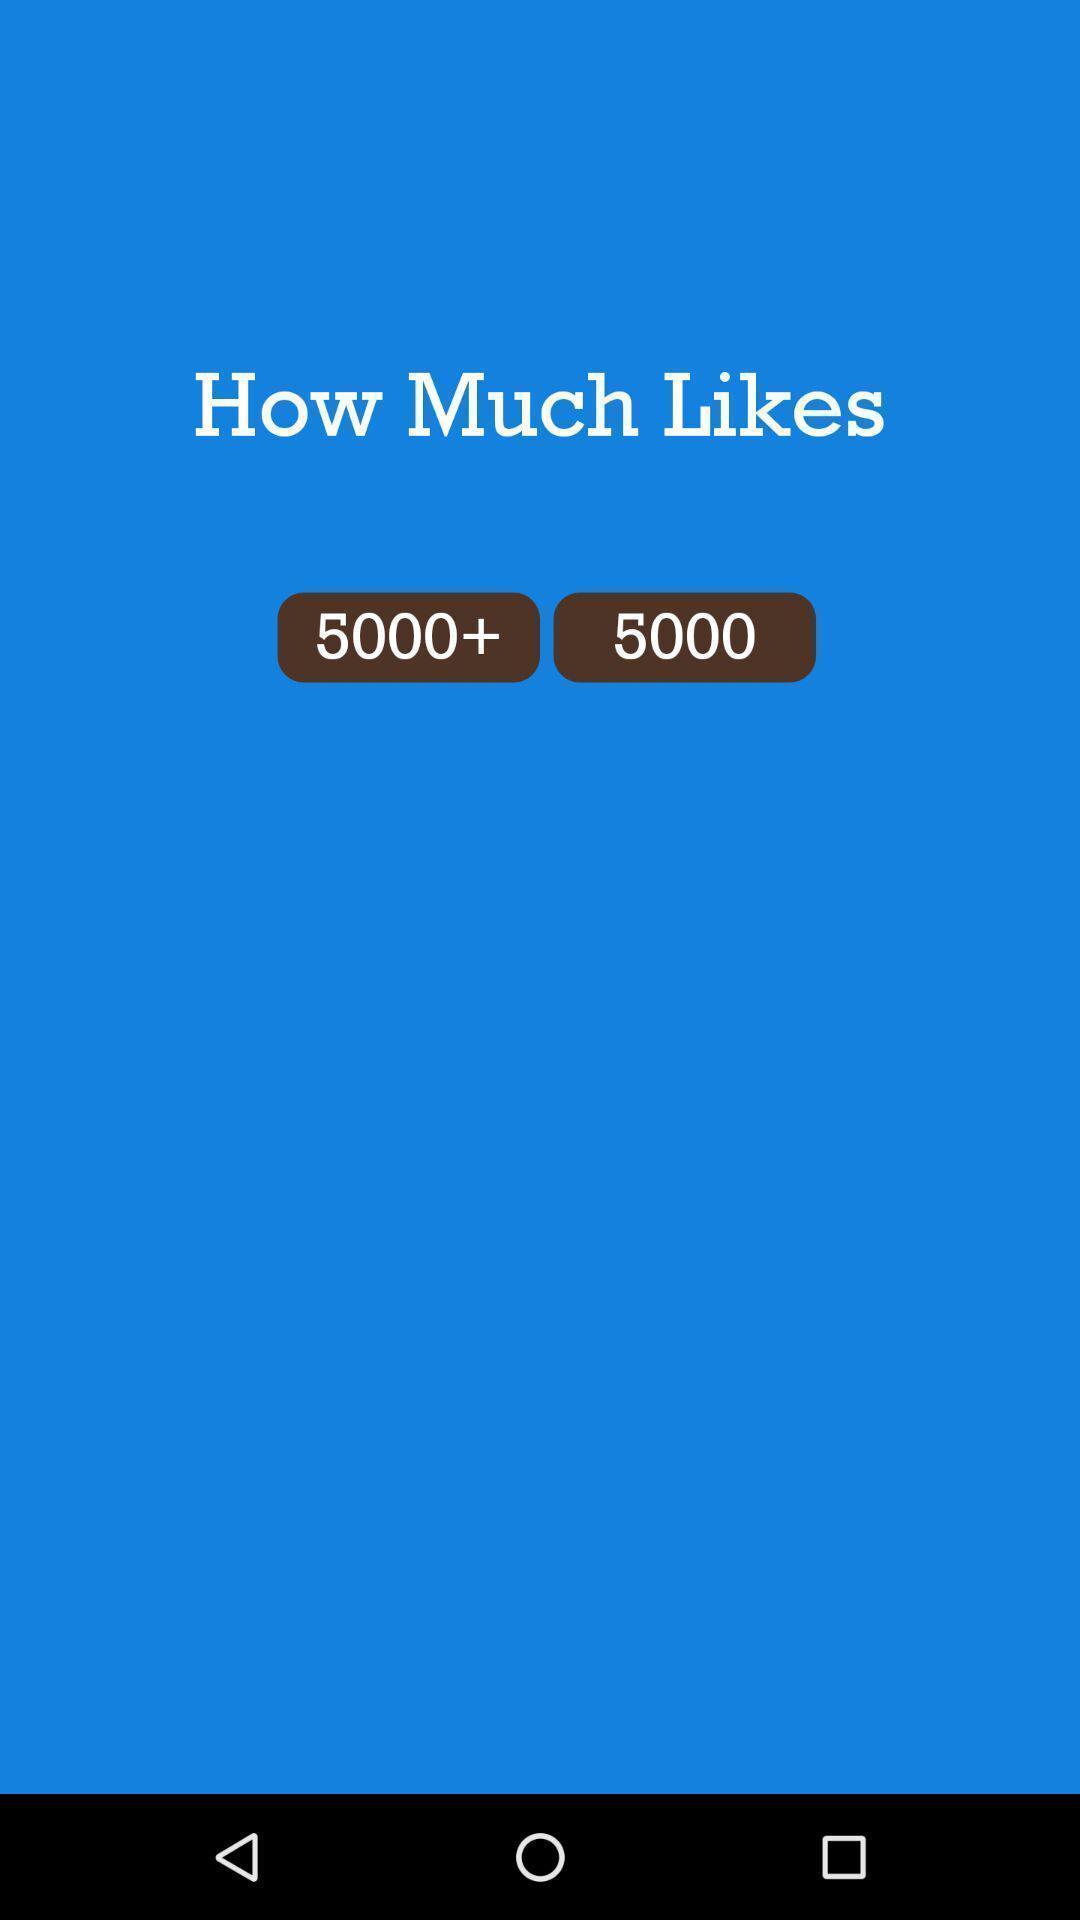Describe the visual elements of this screenshot. Page displaying the question with two answer options. 